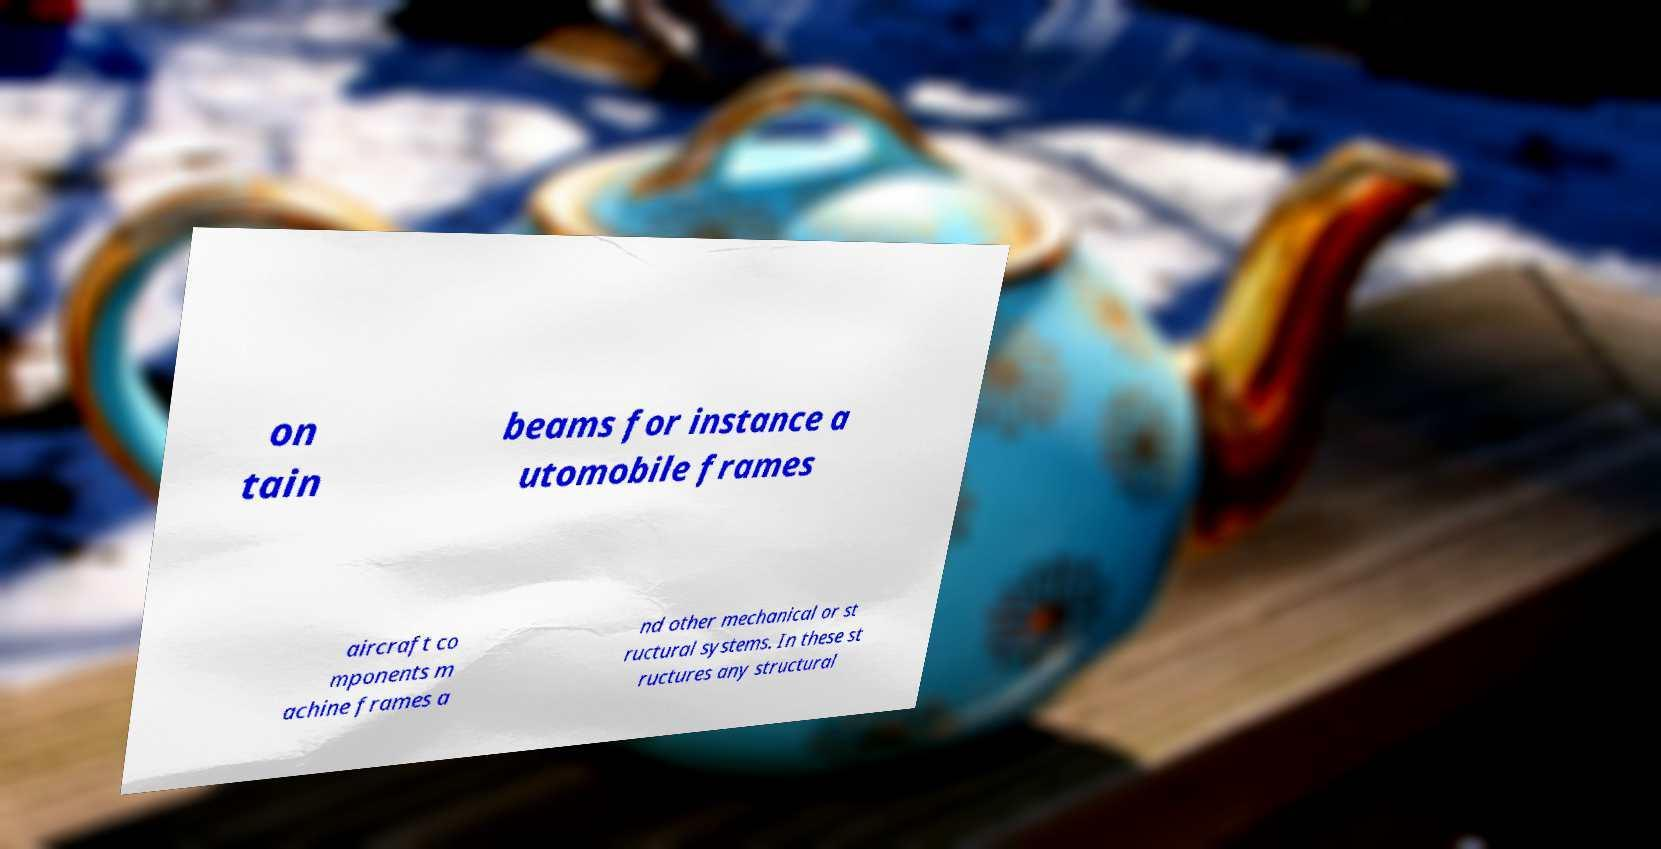I need the written content from this picture converted into text. Can you do that? on tain beams for instance a utomobile frames aircraft co mponents m achine frames a nd other mechanical or st ructural systems. In these st ructures any structural 